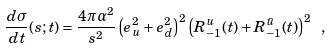Convert formula to latex. <formula><loc_0><loc_0><loc_500><loc_500>\frac { d \sigma } { d t } ( s ; t ) = \frac { 4 \pi \alpha ^ { 2 } } { s ^ { 2 } } \left ( e _ { u } ^ { 2 } + e _ { d } ^ { 2 } \right ) ^ { 2 } \left ( R _ { - 1 } ^ { u } ( t ) + R _ { - 1 } ^ { \bar { u } } ( t ) \right ) ^ { 2 } \ ,</formula> 